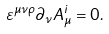Convert formula to latex. <formula><loc_0><loc_0><loc_500><loc_500>\varepsilon ^ { \mu \nu \rho } \partial _ { \nu } A ^ { i } _ { \mu } = 0 .</formula> 